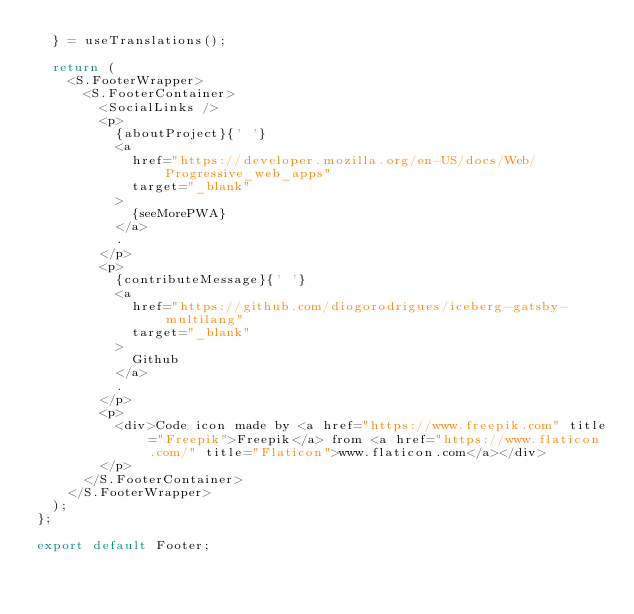Convert code to text. <code><loc_0><loc_0><loc_500><loc_500><_JavaScript_>  } = useTranslations();

  return (
    <S.FooterWrapper>
      <S.FooterContainer>
        <SocialLinks />
        <p>
          {aboutProject}{' '}
          <a
            href="https://developer.mozilla.org/en-US/docs/Web/Progressive_web_apps"
            target="_blank"
          >
            {seeMorePWA}
          </a>
          .
        </p>
        <p>
          {contributeMessage}{' '}
          <a
            href="https://github.com/diogorodrigues/iceberg-gatsby-multilang"
            target="_blank"
          >
            Github
          </a>
          .
        </p>
        <p>
          <div>Code icon made by <a href="https://www.freepik.com" title="Freepik">Freepik</a> from <a href="https://www.flaticon.com/" title="Flaticon">www.flaticon.com</a></div>
        </p>
      </S.FooterContainer>
    </S.FooterWrapper>
  );
};

export default Footer;
</code> 